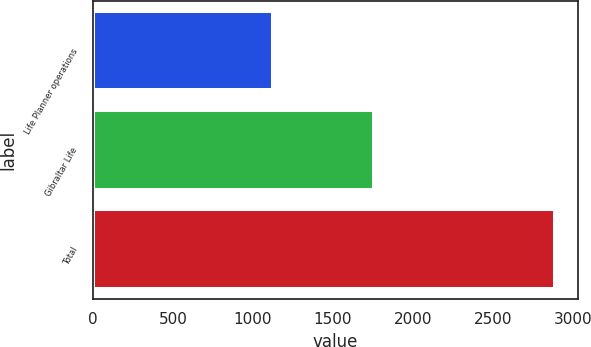Convert chart to OTSL. <chart><loc_0><loc_0><loc_500><loc_500><bar_chart><fcel>Life Planner operations<fcel>Gibraltar Life<fcel>Total<nl><fcel>1128<fcel>1756<fcel>2884<nl></chart> 